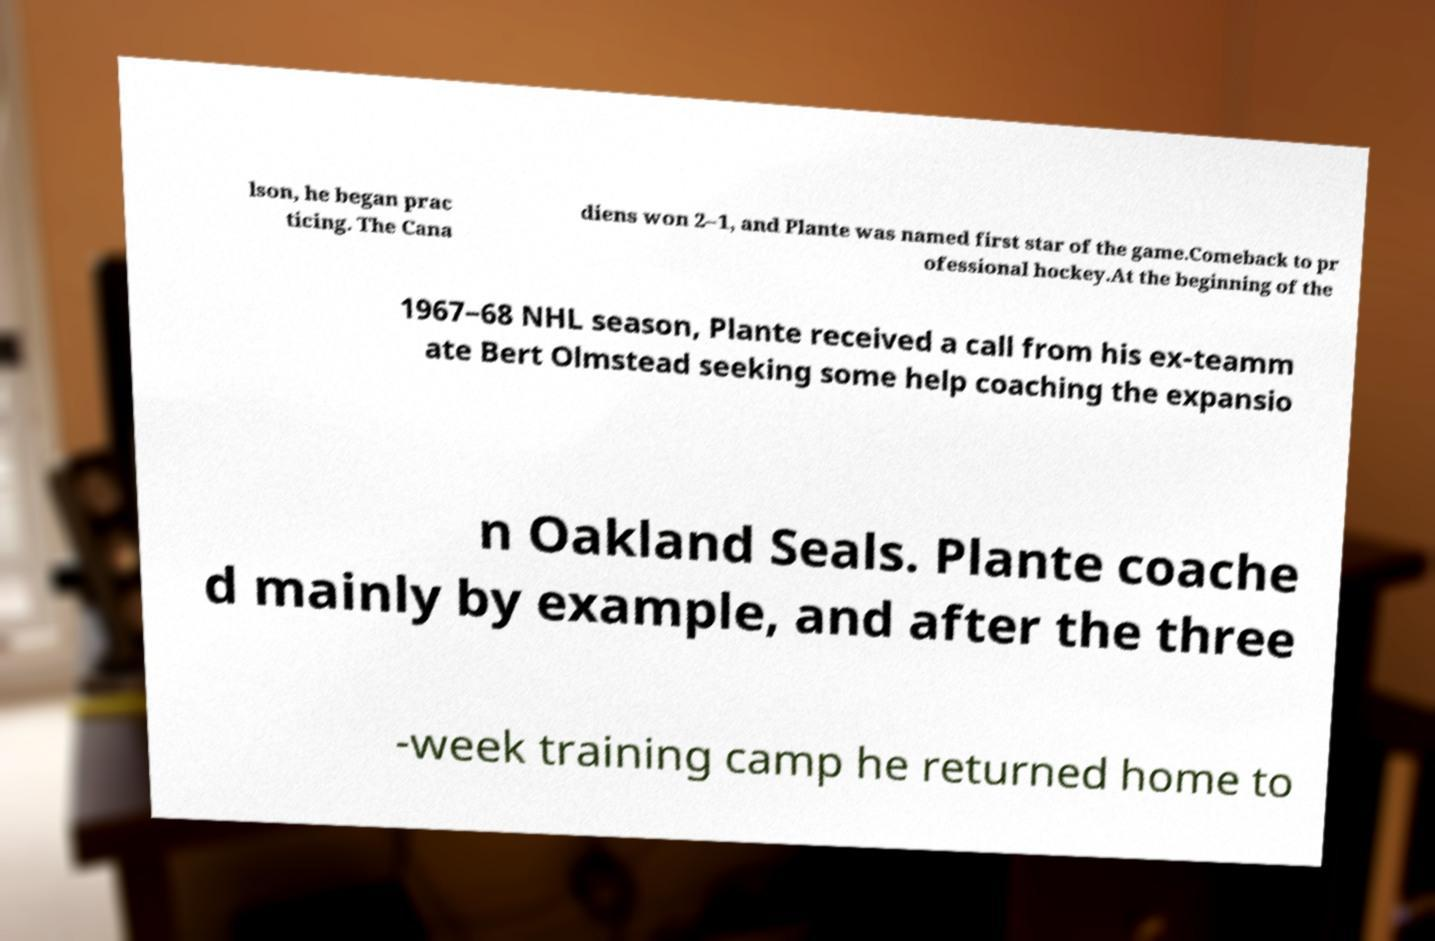I need the written content from this picture converted into text. Can you do that? lson, he began prac ticing. The Cana diens won 2–1, and Plante was named first star of the game.Comeback to pr ofessional hockey.At the beginning of the 1967–68 NHL season, Plante received a call from his ex-teamm ate Bert Olmstead seeking some help coaching the expansio n Oakland Seals. Plante coache d mainly by example, and after the three -week training camp he returned home to 